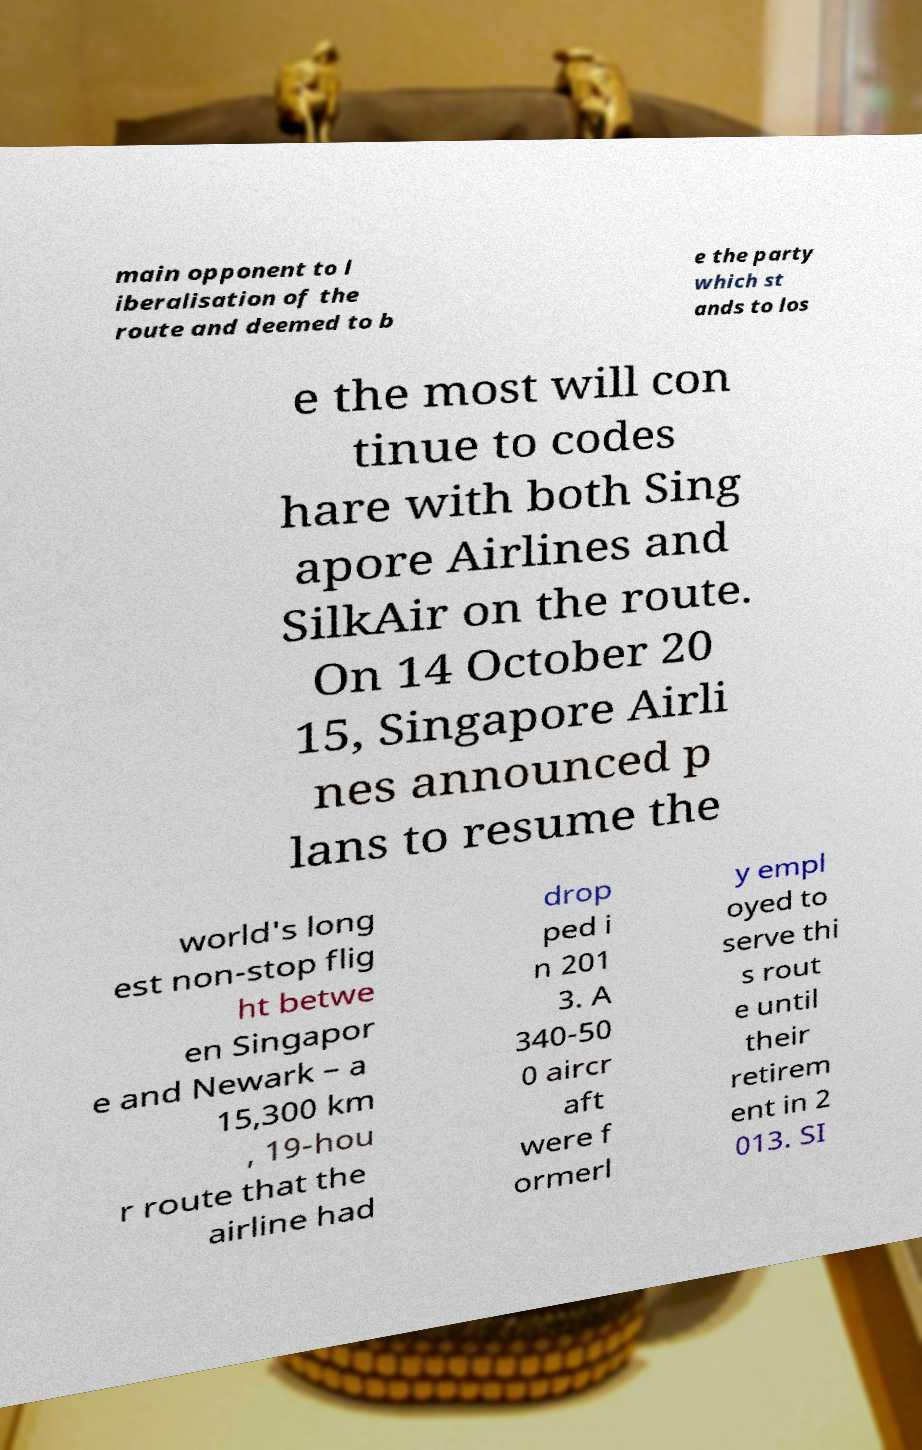Could you assist in decoding the text presented in this image and type it out clearly? main opponent to l iberalisation of the route and deemed to b e the party which st ands to los e the most will con tinue to codes hare with both Sing apore Airlines and SilkAir on the route. On 14 October 20 15, Singapore Airli nes announced p lans to resume the world's long est non-stop flig ht betwe en Singapor e and Newark – a 15,300 km , 19-hou r route that the airline had drop ped i n 201 3. A 340-50 0 aircr aft were f ormerl y empl oyed to serve thi s rout e until their retirem ent in 2 013. SI 